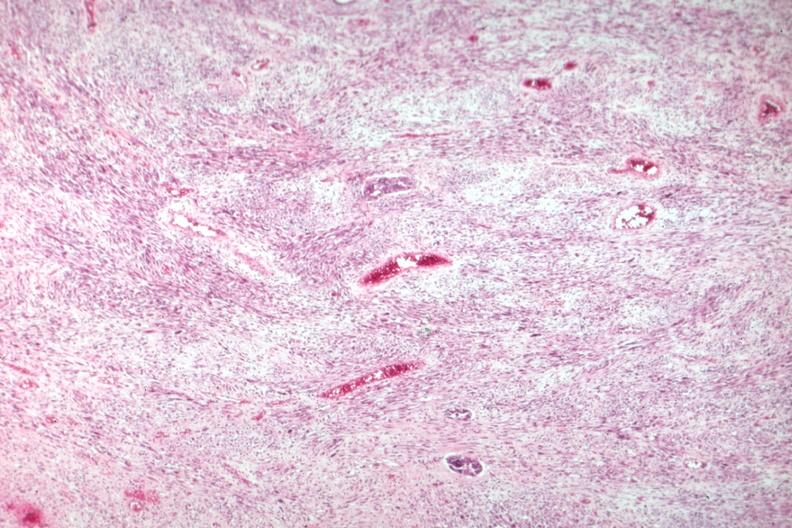s nodular tumor present?
Answer the question using a single word or phrase. No 